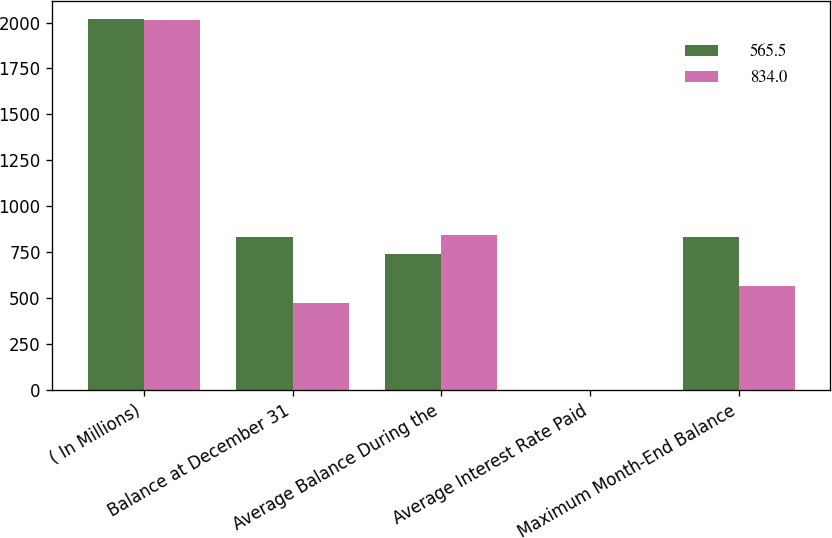Convert chart. <chart><loc_0><loc_0><loc_500><loc_500><stacked_bar_chart><ecel><fcel>( In Millions)<fcel>Balance at December 31<fcel>Average Balance During the<fcel>Average Interest Rate Paid<fcel>Maximum Month-End Balance<nl><fcel>565.5<fcel>2017<fcel>834<fcel>738.9<fcel>0.81<fcel>834<nl><fcel>834<fcel>2016<fcel>473.7<fcel>847.1<fcel>0.27<fcel>565.5<nl></chart> 